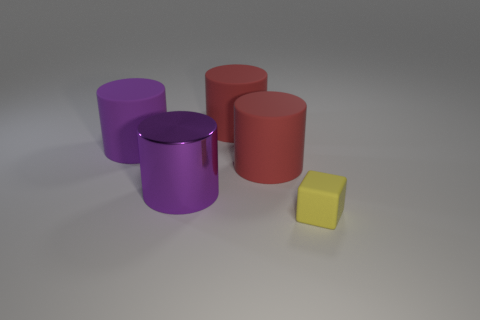Subtract all yellow cylinders. Subtract all purple cubes. How many cylinders are left? 4 Add 5 cylinders. How many objects exist? 10 Subtract all blocks. How many objects are left? 4 Add 2 purple rubber objects. How many purple rubber objects are left? 3 Add 1 large brown things. How many large brown things exist? 1 Subtract 0 blue blocks. How many objects are left? 5 Subtract all small things. Subtract all purple rubber cylinders. How many objects are left? 3 